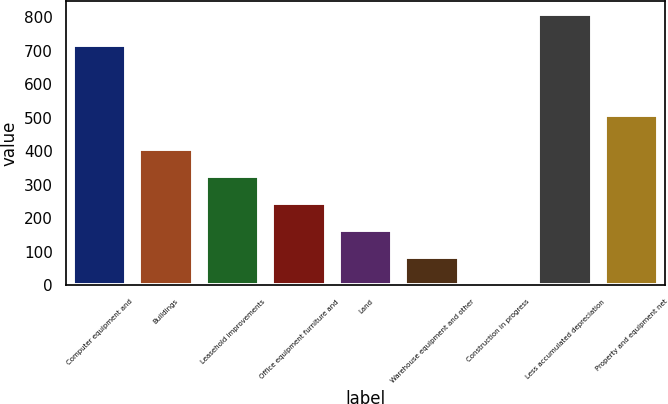Convert chart. <chart><loc_0><loc_0><loc_500><loc_500><bar_chart><fcel>Computer equipment and<fcel>Buildings<fcel>Leasehold improvements<fcel>Office equipment furniture and<fcel>Land<fcel>Warehouse equipment and other<fcel>Construction in progress<fcel>Less accumulated depreciation<fcel>Property and equipment net<nl><fcel>718<fcel>407<fcel>326.6<fcel>246.2<fcel>165.8<fcel>85.4<fcel>5<fcel>809<fcel>510<nl></chart> 